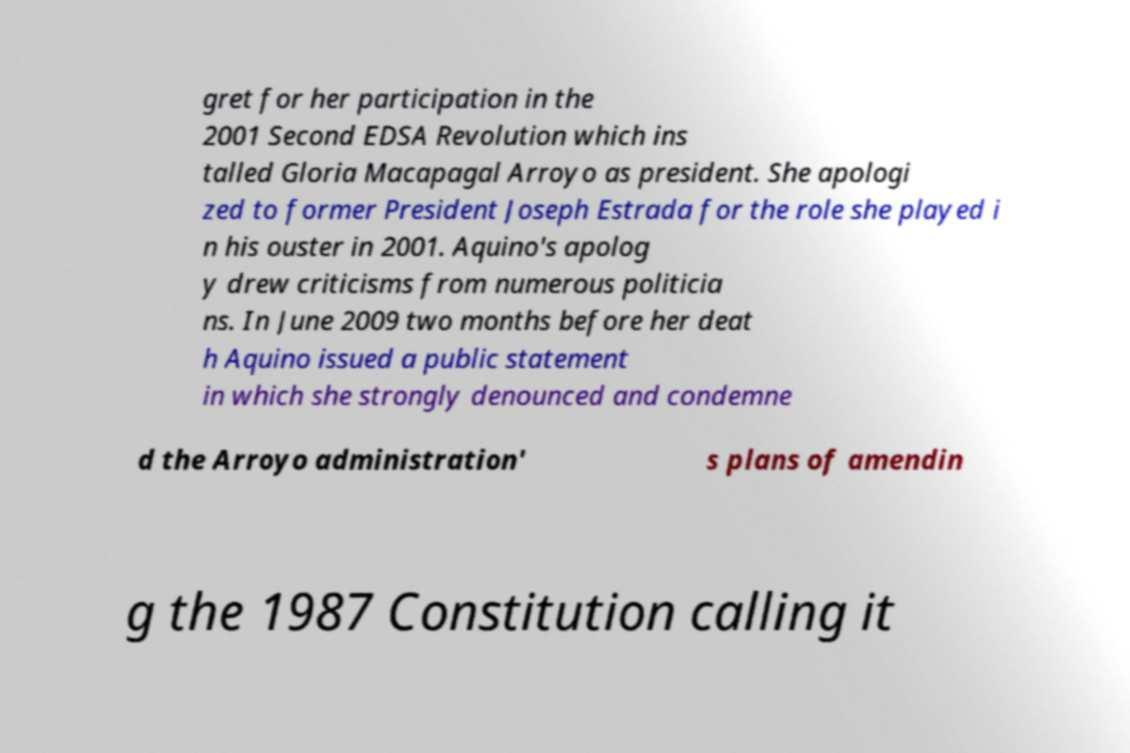Please read and relay the text visible in this image. What does it say? gret for her participation in the 2001 Second EDSA Revolution which ins talled Gloria Macapagal Arroyo as president. She apologi zed to former President Joseph Estrada for the role she played i n his ouster in 2001. Aquino's apolog y drew criticisms from numerous politicia ns. In June 2009 two months before her deat h Aquino issued a public statement in which she strongly denounced and condemne d the Arroyo administration' s plans of amendin g the 1987 Constitution calling it 